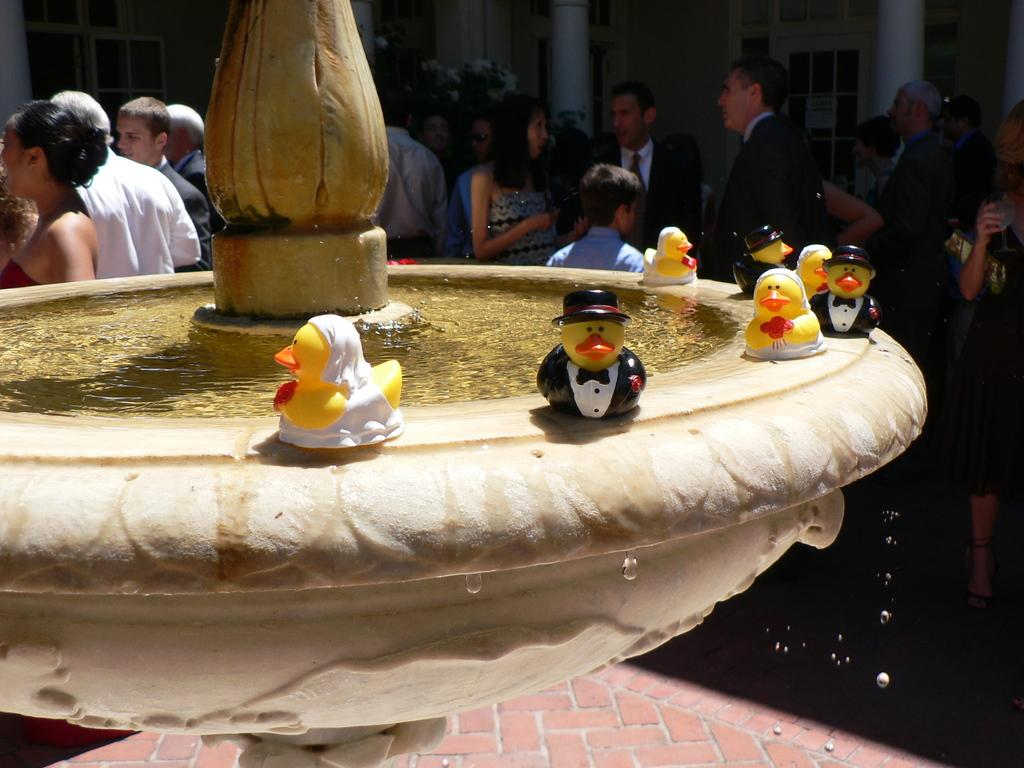What can be seen in the image? There are people standing in the image. Where are the people standing? The people are standing on the floor. What is visible in the background of the image? There is a fountain in the background of the image. What is placed on the fountain? Toys are placed on the fountain. What type of reward is the grandfather giving to the people in the image? There is no grandfather or reward present in the image. How many doors can be seen in the image? There are no doors visible in the image. 